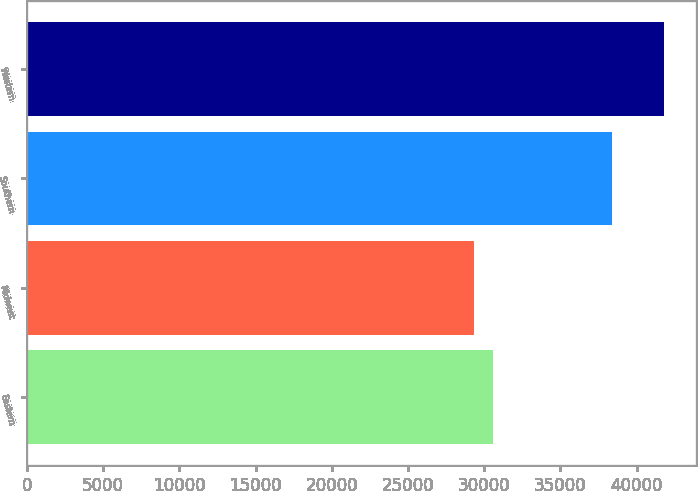<chart> <loc_0><loc_0><loc_500><loc_500><bar_chart><fcel>Eastern<fcel>Midwest<fcel>Southern<fcel>Western<nl><fcel>30604<fcel>29357<fcel>38409<fcel>41827<nl></chart> 